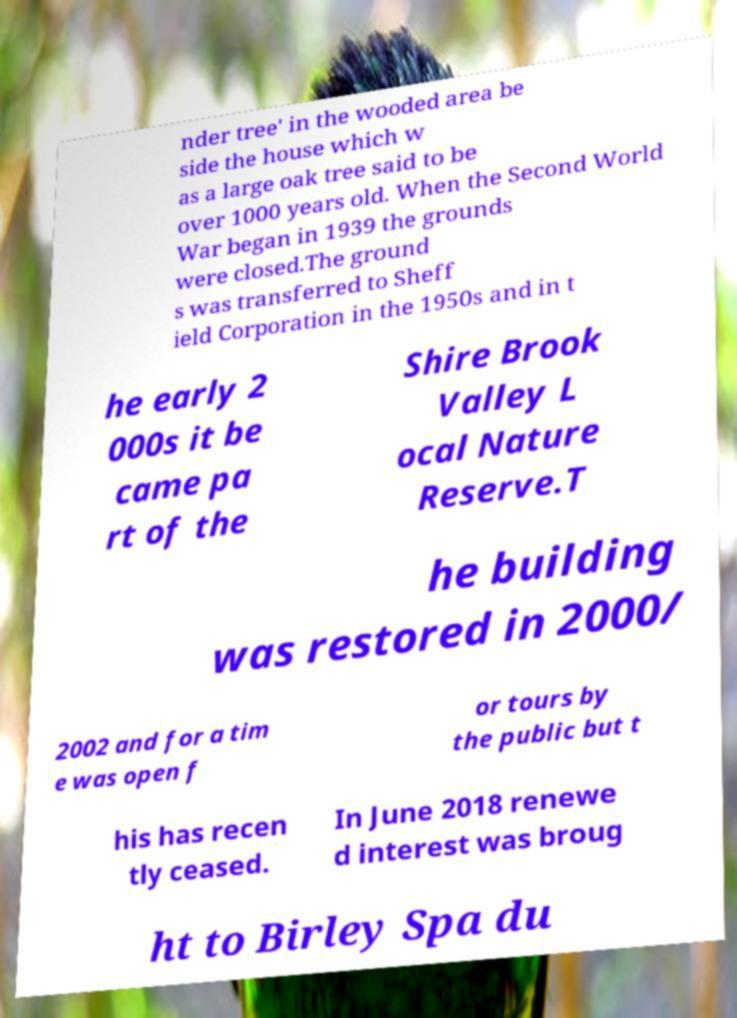What messages or text are displayed in this image? I need them in a readable, typed format. nder tree' in the wooded area be side the house which w as a large oak tree said to be over 1000 years old. When the Second World War began in 1939 the grounds were closed.The ground s was transferred to Sheff ield Corporation in the 1950s and in t he early 2 000s it be came pa rt of the Shire Brook Valley L ocal Nature Reserve.T he building was restored in 2000/ 2002 and for a tim e was open f or tours by the public but t his has recen tly ceased. In June 2018 renewe d interest was broug ht to Birley Spa du 